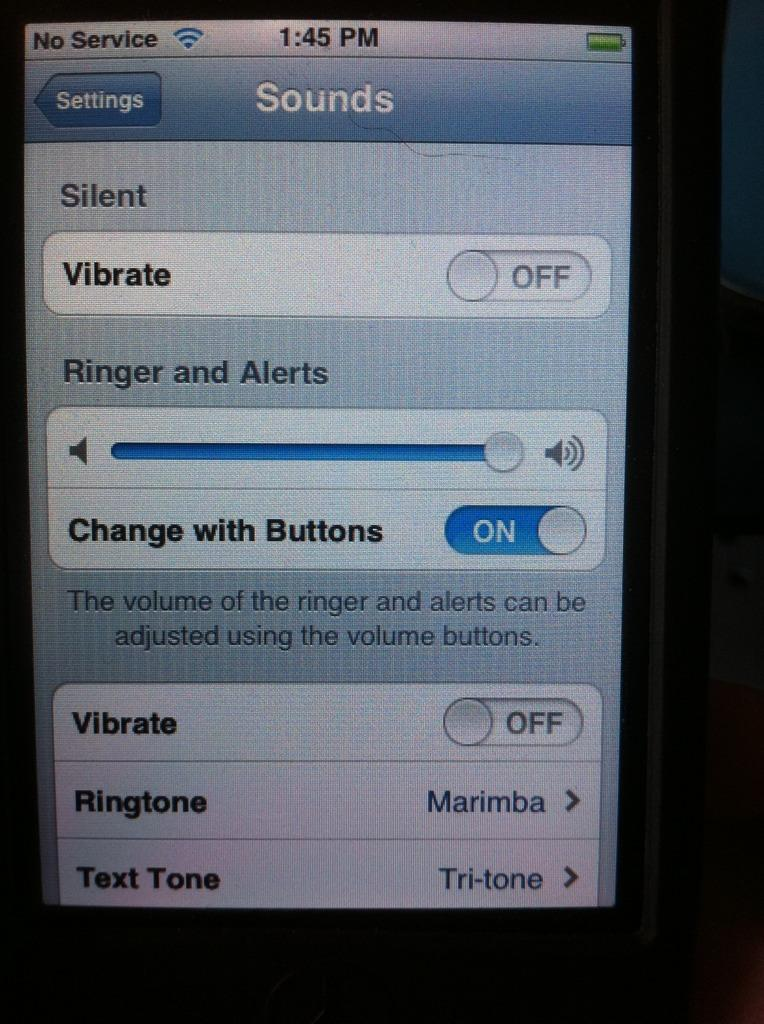<image>
Present a compact description of the photo's key features. The settings screen is displayed on a cell phone. 